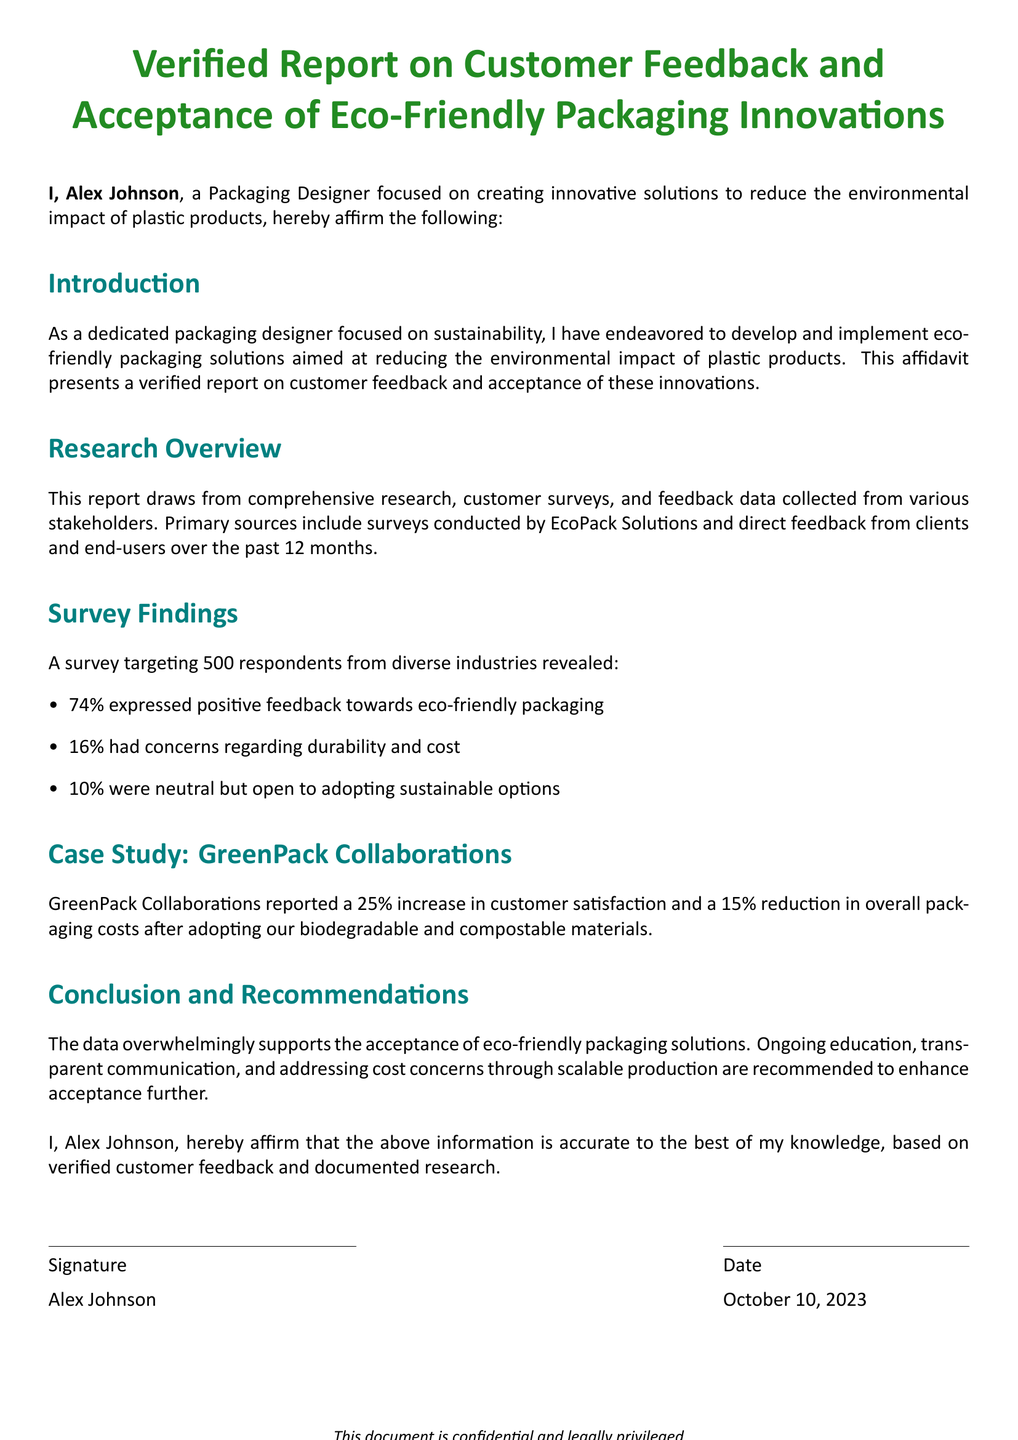What is the name of the affiant? The document states that the name of the affiant is Alex Johnson.
Answer: Alex Johnson What is the primary focus of Alex Johnson's work? The document indicates that Alex Johnson is focused on creating innovative solutions to reduce the environmental impact of plastic products.
Answer: Environmental impact of plastic products How many respondents were surveyed for the research? The report mentions that 500 respondents were surveyed.
Answer: 500 What percentage of respondents expressed positive feedback towards eco-friendly packaging? The survey findings indicate that 74% expressed positive feedback.
Answer: 74% What increase in customer satisfaction did GreenPack Collaborations report? The document states that GreenPack Collaborations reported a 25% increase in customer satisfaction.
Answer: 25% What concerns did some respondents have regarding eco-friendly packaging? The document highlights that 16% of respondents had concerns regarding durability and cost.
Answer: Durability and cost What recommendation is given to enhance acceptance of eco-friendly packaging? The document provides several recommendations, including ongoing education and transparent communication.
Answer: Ongoing education When was the affidavit signed? The document specifies that the affidavit was signed on October 10, 2023.
Answer: October 10, 2023 